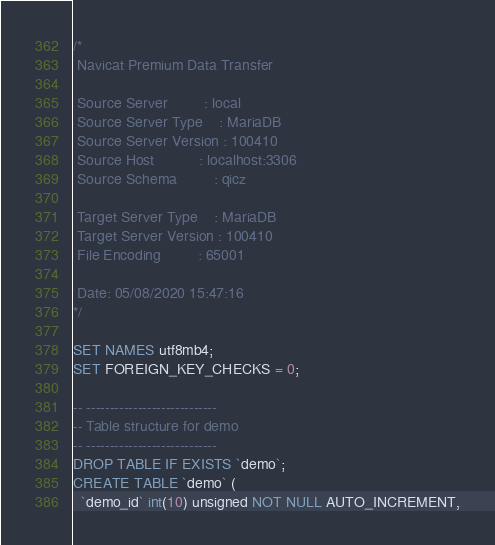Convert code to text. <code><loc_0><loc_0><loc_500><loc_500><_SQL_>/*
 Navicat Premium Data Transfer

 Source Server         : local
 Source Server Type    : MariaDB
 Source Server Version : 100410
 Source Host           : localhost:3306
 Source Schema         : qicz

 Target Server Type    : MariaDB
 Target Server Version : 100410
 File Encoding         : 65001

 Date: 05/08/2020 15:47:16
*/

SET NAMES utf8mb4;
SET FOREIGN_KEY_CHECKS = 0;

-- ----------------------------
-- Table structure for demo
-- ----------------------------
DROP TABLE IF EXISTS `demo`;
CREATE TABLE `demo` (
  `demo_id` int(10) unsigned NOT NULL AUTO_INCREMENT,</code> 